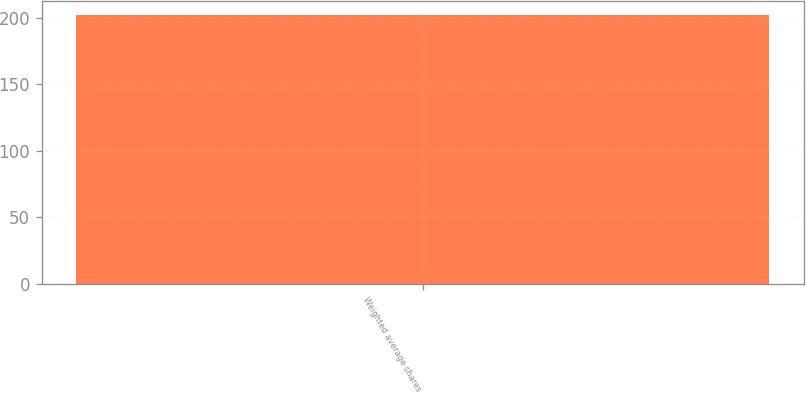Convert chart to OTSL. <chart><loc_0><loc_0><loc_500><loc_500><bar_chart><fcel>Weighted average shares<nl><fcel>202.4<nl></chart> 